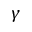<formula> <loc_0><loc_0><loc_500><loc_500>\gamma</formula> 